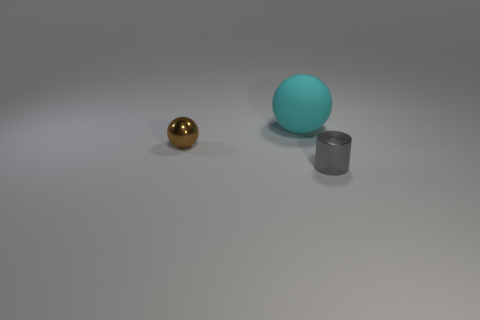There is a brown object that is the same material as the gray thing; what is its shape?
Give a very brief answer. Sphere. There is a brown object; does it have the same size as the ball behind the tiny brown metallic sphere?
Make the answer very short. No. Are there more metallic cylinders that are to the right of the tiny ball than cyan metal balls?
Your answer should be very brief. Yes. What number of cylinders have the same size as the cyan rubber object?
Your answer should be compact. 0. Do the metal object that is behind the small cylinder and the metallic object that is on the right side of the tiny metallic sphere have the same size?
Give a very brief answer. Yes. Is the number of small metal balls that are left of the small brown thing greater than the number of tiny gray shiny cylinders left of the cyan thing?
Offer a very short reply. No. How many small purple things have the same shape as the large cyan rubber object?
Give a very brief answer. 0. There is another thing that is the same size as the brown metal thing; what is it made of?
Provide a succinct answer. Metal. Are there any other big objects that have the same material as the brown object?
Offer a terse response. No. Are there fewer small metal balls that are behind the small brown object than small brown spheres?
Ensure brevity in your answer.  Yes. 